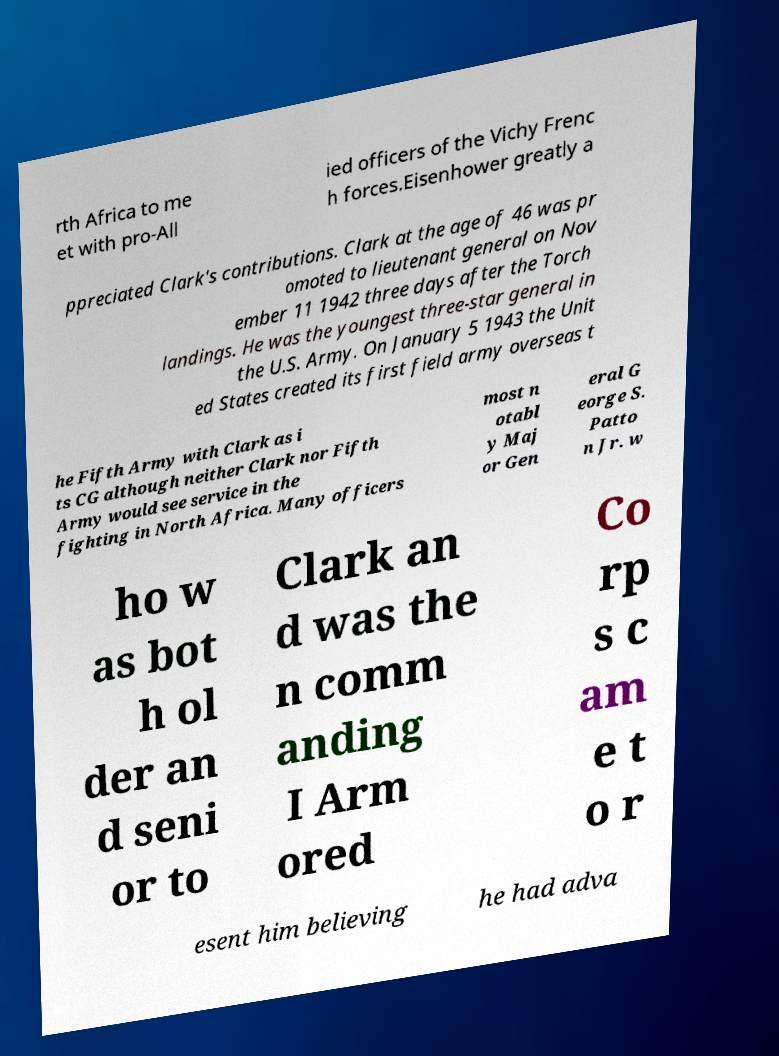I need the written content from this picture converted into text. Can you do that? rth Africa to me et with pro-All ied officers of the Vichy Frenc h forces.Eisenhower greatly a ppreciated Clark's contributions. Clark at the age of 46 was pr omoted to lieutenant general on Nov ember 11 1942 three days after the Torch landings. He was the youngest three-star general in the U.S. Army. On January 5 1943 the Unit ed States created its first field army overseas t he Fifth Army with Clark as i ts CG although neither Clark nor Fifth Army would see service in the fighting in North Africa. Many officers most n otabl y Maj or Gen eral G eorge S. Patto n Jr. w ho w as bot h ol der an d seni or to Clark an d was the n comm anding I Arm ored Co rp s c am e t o r esent him believing he had adva 